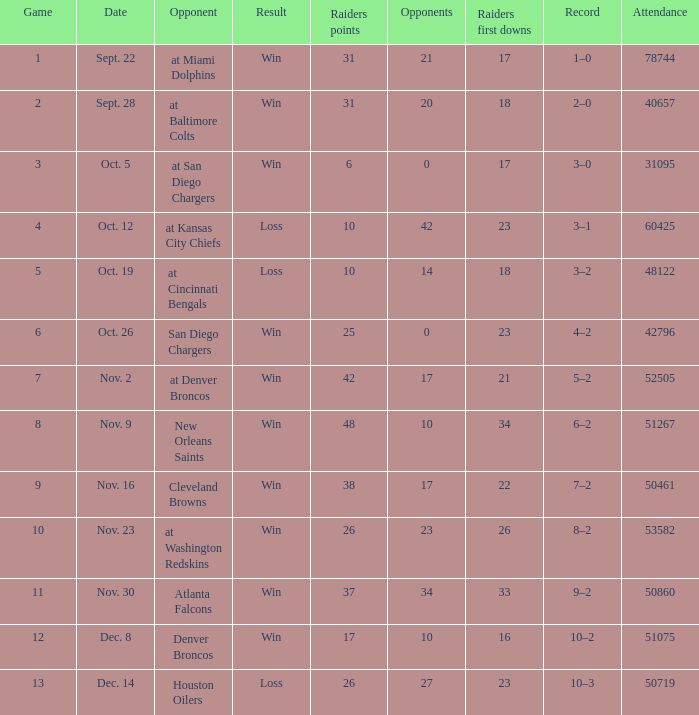What was the result of the game seen by 31095 people? Win. 